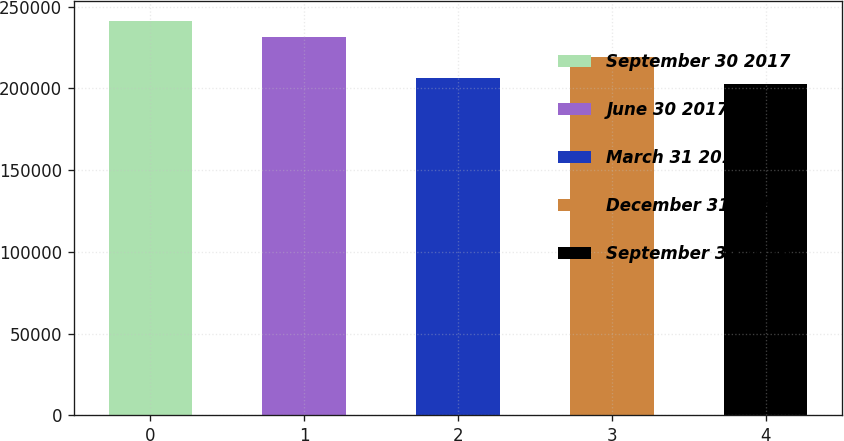Convert chart. <chart><loc_0><loc_0><loc_500><loc_500><bar_chart><fcel>September 30 2017<fcel>June 30 2017<fcel>March 31 2017<fcel>December 31 2016<fcel>September 30 2016<nl><fcel>241365<fcel>231378<fcel>206555<fcel>219095<fcel>202687<nl></chart> 